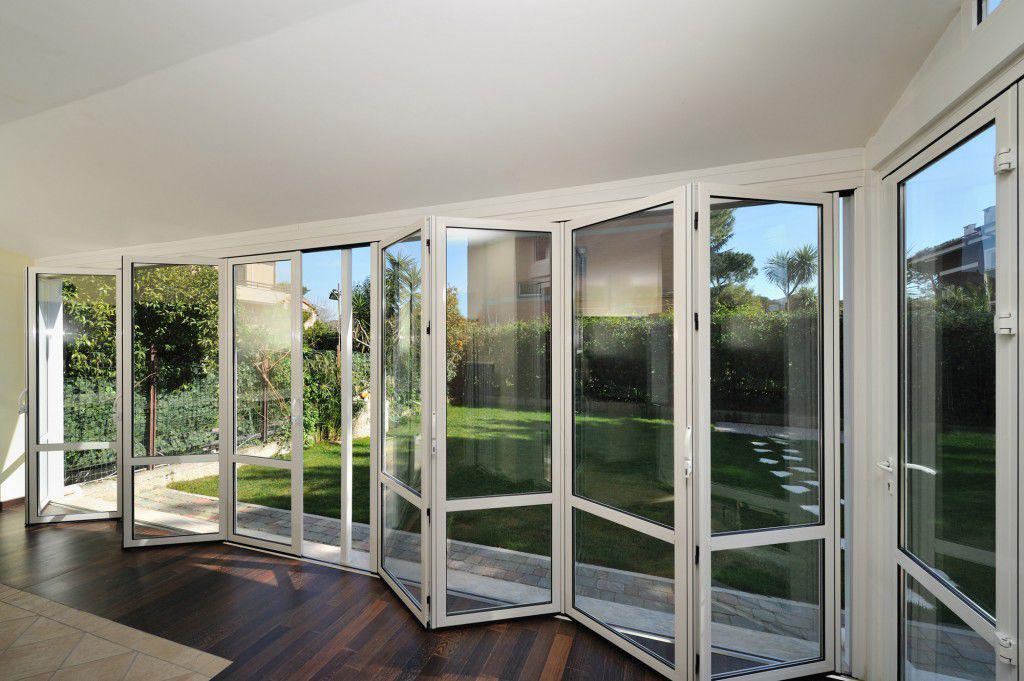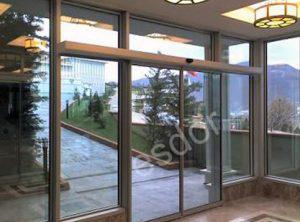The first image is the image on the left, the second image is the image on the right. Considering the images on both sides, is "The right image shows columns wth cap tops next to a wall of sliding glass doors and glass windows." valid? Answer yes or no. No. The first image is the image on the left, the second image is the image on the right. Given the left and right images, does the statement "Doors are open in both images." hold true? Answer yes or no. No. 